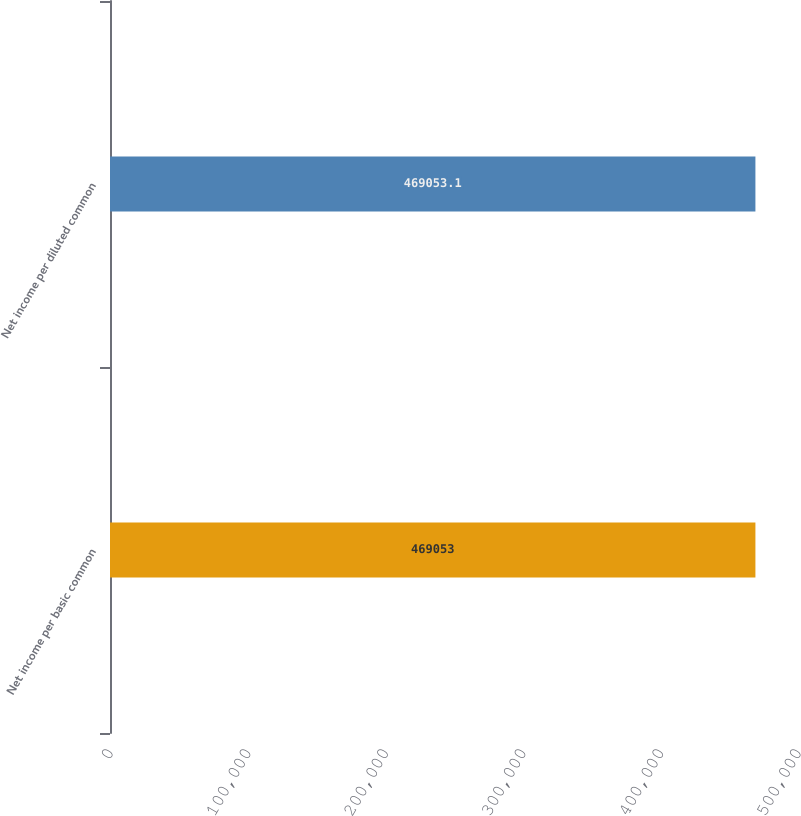Convert chart. <chart><loc_0><loc_0><loc_500><loc_500><bar_chart><fcel>Net income per basic common<fcel>Net income per diluted common<nl><fcel>469053<fcel>469053<nl></chart> 